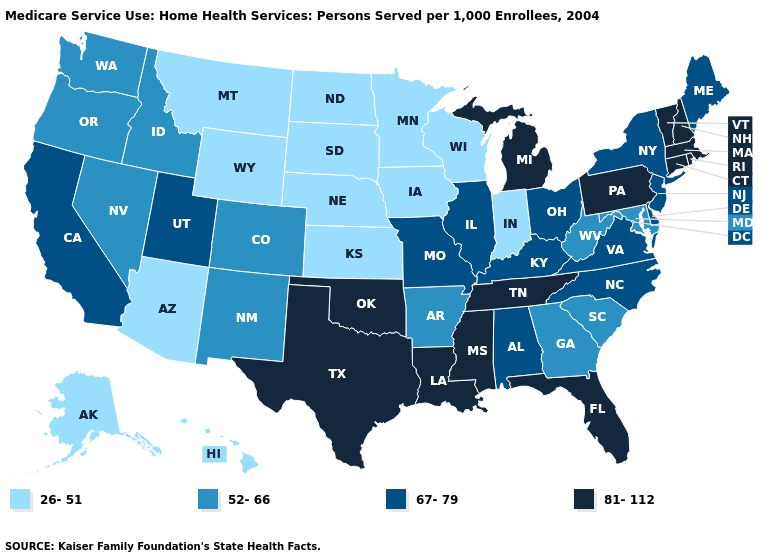What is the value of Nebraska?
Quick response, please. 26-51. What is the lowest value in the USA?
Give a very brief answer. 26-51. Which states have the lowest value in the MidWest?
Be succinct. Indiana, Iowa, Kansas, Minnesota, Nebraska, North Dakota, South Dakota, Wisconsin. Which states have the lowest value in the Northeast?
Keep it brief. Maine, New Jersey, New York. Does Massachusetts have the highest value in the USA?
Keep it brief. Yes. Name the states that have a value in the range 52-66?
Be succinct. Arkansas, Colorado, Georgia, Idaho, Maryland, Nevada, New Mexico, Oregon, South Carolina, Washington, West Virginia. What is the highest value in states that border Delaware?
Keep it brief. 81-112. Which states have the highest value in the USA?
Give a very brief answer. Connecticut, Florida, Louisiana, Massachusetts, Michigan, Mississippi, New Hampshire, Oklahoma, Pennsylvania, Rhode Island, Tennessee, Texas, Vermont. What is the value of Idaho?
Answer briefly. 52-66. Does North Dakota have the lowest value in the USA?
Be succinct. Yes. Which states have the lowest value in the USA?
Answer briefly. Alaska, Arizona, Hawaii, Indiana, Iowa, Kansas, Minnesota, Montana, Nebraska, North Dakota, South Dakota, Wisconsin, Wyoming. What is the value of Georgia?
Answer briefly. 52-66. Name the states that have a value in the range 67-79?
Quick response, please. Alabama, California, Delaware, Illinois, Kentucky, Maine, Missouri, New Jersey, New York, North Carolina, Ohio, Utah, Virginia. Which states hav the highest value in the West?
Give a very brief answer. California, Utah. What is the value of Massachusetts?
Short answer required. 81-112. 